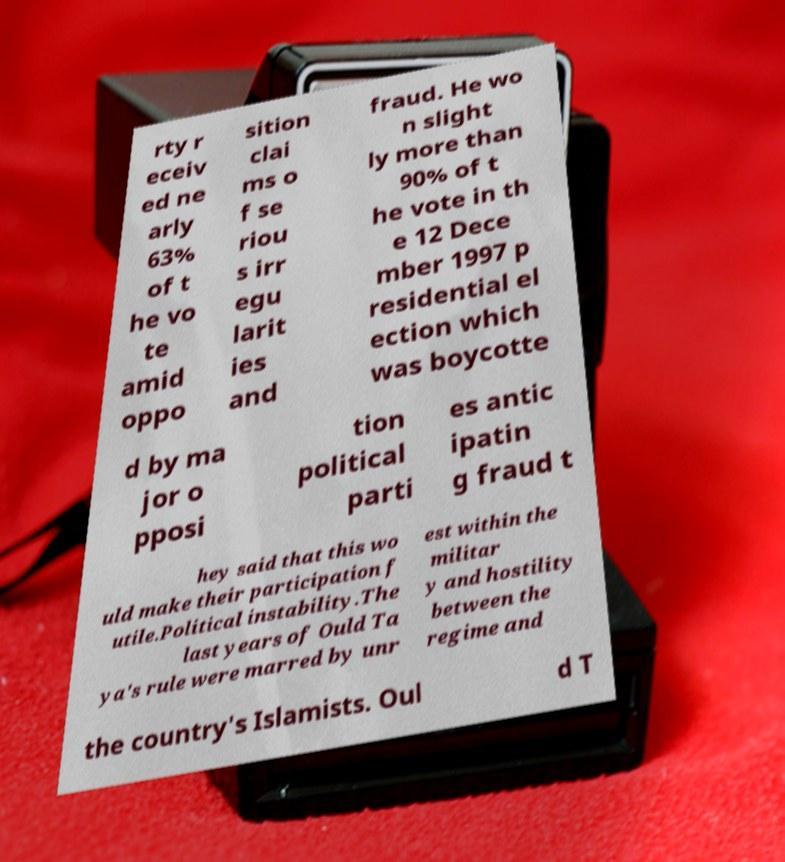I need the written content from this picture converted into text. Can you do that? rty r eceiv ed ne arly 63% of t he vo te amid oppo sition clai ms o f se riou s irr egu larit ies and fraud. He wo n slight ly more than 90% of t he vote in th e 12 Dece mber 1997 p residential el ection which was boycotte d by ma jor o pposi tion political parti es antic ipatin g fraud t hey said that this wo uld make their participation f utile.Political instability.The last years of Ould Ta ya's rule were marred by unr est within the militar y and hostility between the regime and the country's Islamists. Oul d T 